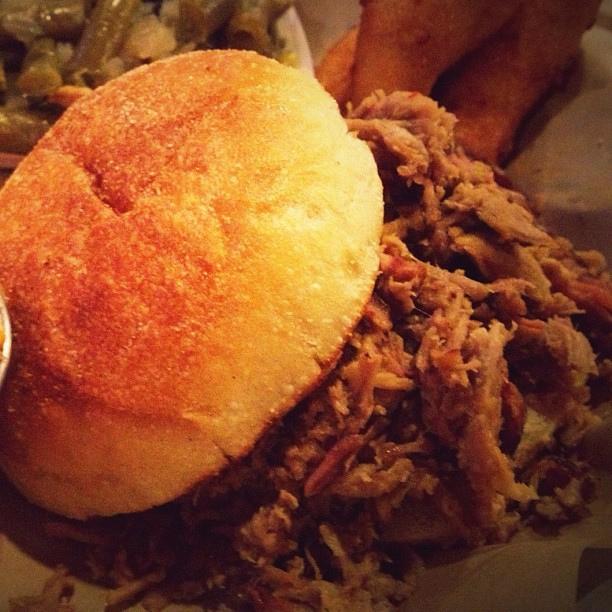Is this a breakfast food?
Short answer required. No. What are the green things in the upper left of the picture?
Quick response, please. Green beans. Is this chicken?
Quick response, please. No. 